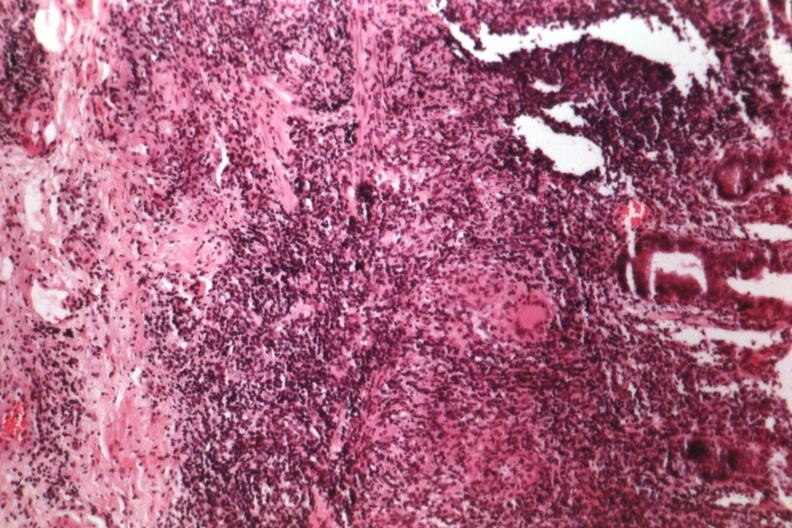s colon present?
Answer the question using a single word or phrase. Yes 